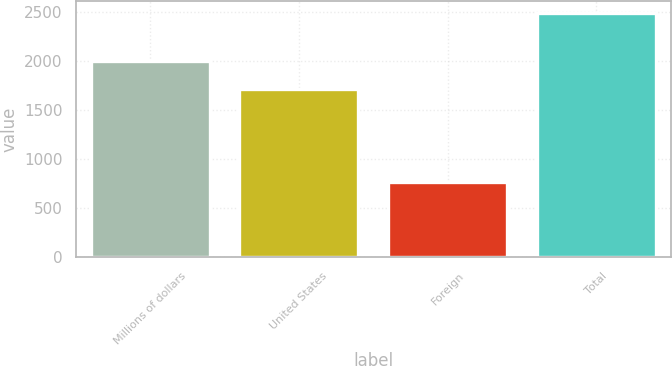<chart> <loc_0><loc_0><loc_500><loc_500><bar_chart><fcel>Millions of dollars<fcel>United States<fcel>Foreign<fcel>Total<nl><fcel>2005<fcel>1721<fcel>771<fcel>2492<nl></chart> 